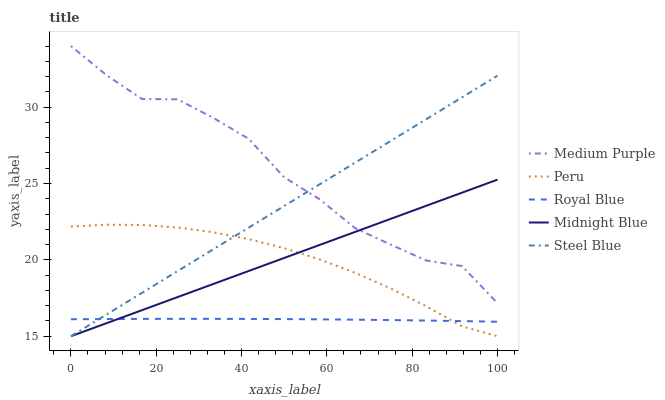Does Royal Blue have the minimum area under the curve?
Answer yes or no. Yes. Does Medium Purple have the maximum area under the curve?
Answer yes or no. Yes. Does Midnight Blue have the minimum area under the curve?
Answer yes or no. No. Does Midnight Blue have the maximum area under the curve?
Answer yes or no. No. Is Midnight Blue the smoothest?
Answer yes or no. Yes. Is Medium Purple the roughest?
Answer yes or no. Yes. Is Royal Blue the smoothest?
Answer yes or no. No. Is Royal Blue the roughest?
Answer yes or no. No. Does Midnight Blue have the lowest value?
Answer yes or no. Yes. Does Royal Blue have the lowest value?
Answer yes or no. No. Does Medium Purple have the highest value?
Answer yes or no. Yes. Does Midnight Blue have the highest value?
Answer yes or no. No. Is Peru less than Medium Purple?
Answer yes or no. Yes. Is Medium Purple greater than Royal Blue?
Answer yes or no. Yes. Does Peru intersect Steel Blue?
Answer yes or no. Yes. Is Peru less than Steel Blue?
Answer yes or no. No. Is Peru greater than Steel Blue?
Answer yes or no. No. Does Peru intersect Medium Purple?
Answer yes or no. No. 